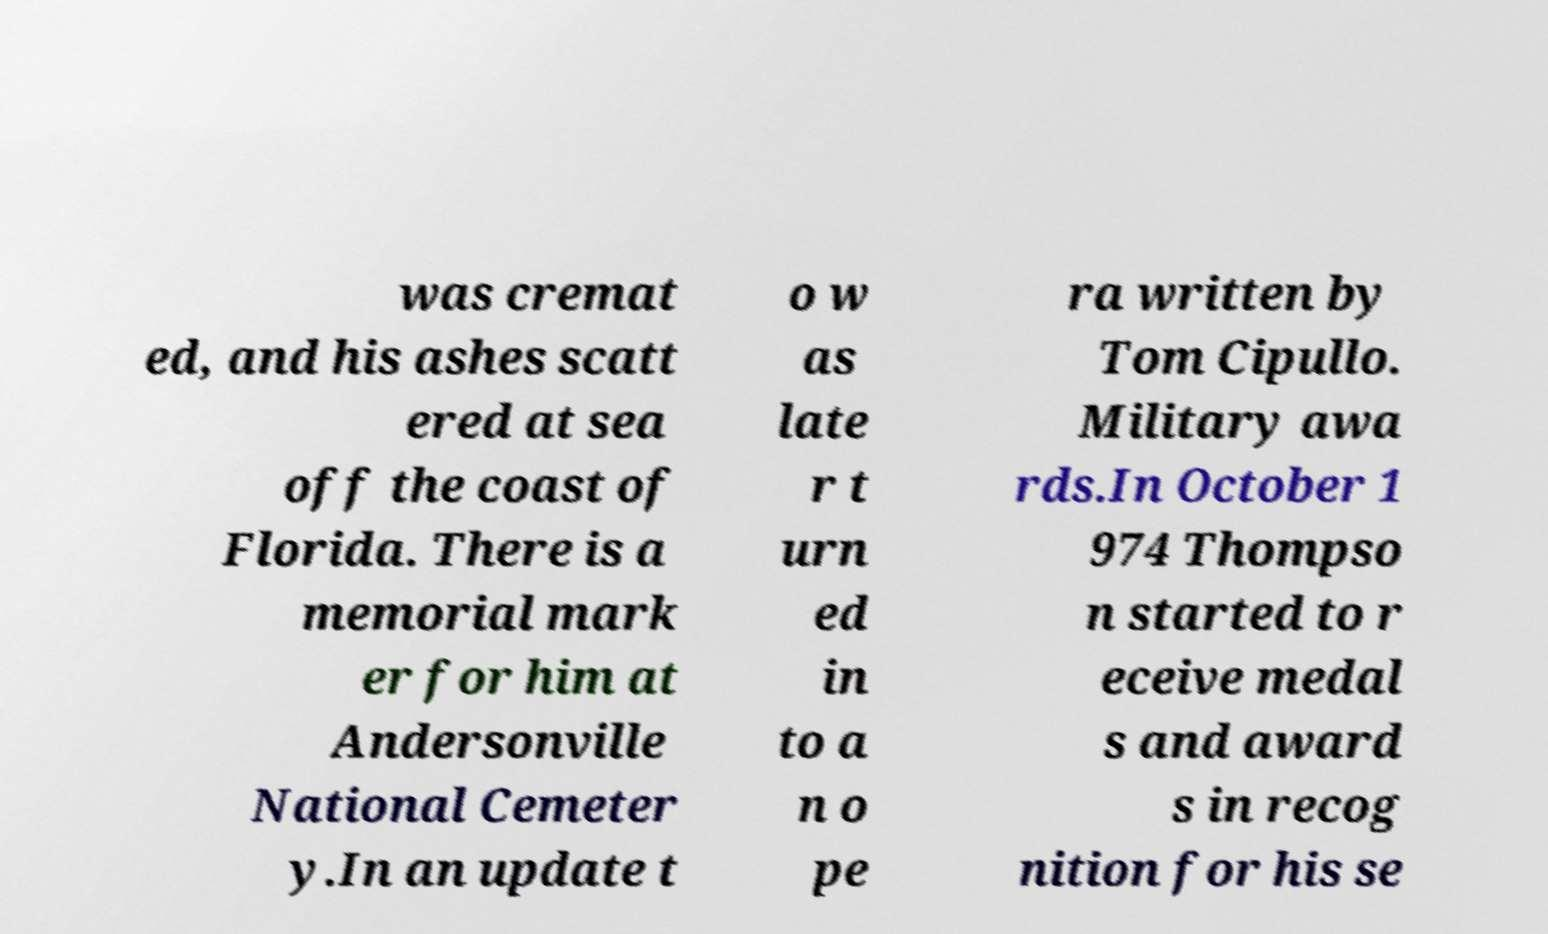Please read and relay the text visible in this image. What does it say? was cremat ed, and his ashes scatt ered at sea off the coast of Florida. There is a memorial mark er for him at Andersonville National Cemeter y.In an update t o w as late r t urn ed in to a n o pe ra written by Tom Cipullo. Military awa rds.In October 1 974 Thompso n started to r eceive medal s and award s in recog nition for his se 